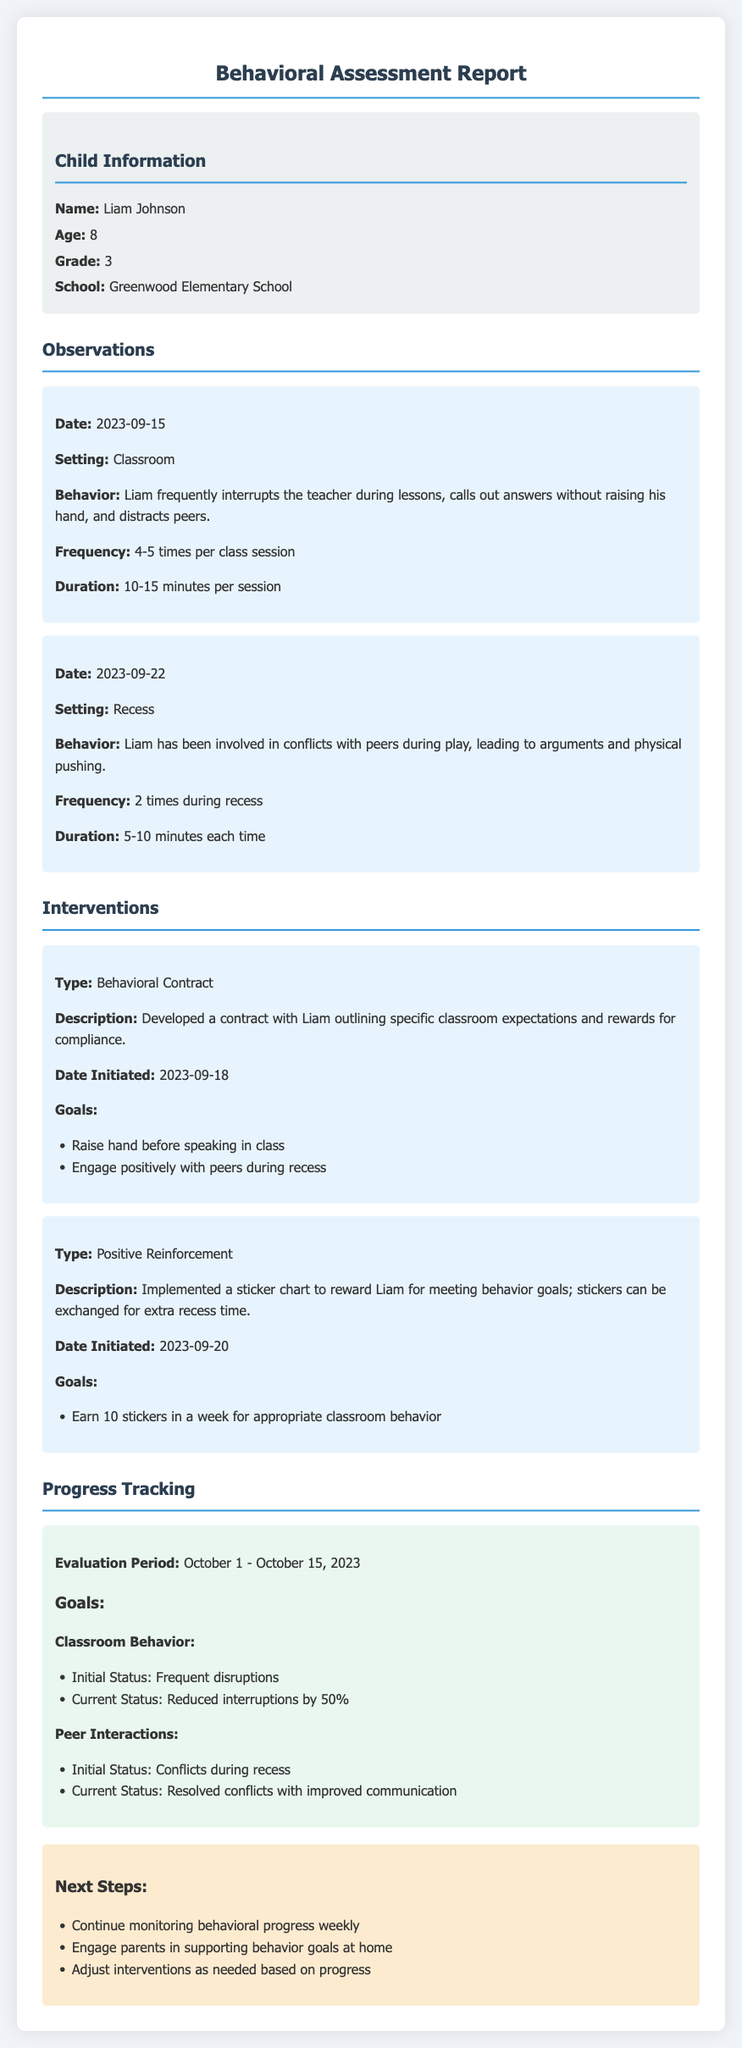What is the child's name? The child's name is stated in the child information section of the document.
Answer: Liam Johnson How old is Liam? The age of Liam is provided in the child information section.
Answer: 8 What type of behavioral intervention involves a sticker chart? This intervention type is mentioned under the interventions section of the document.
Answer: Positive Reinforcement What was Liam's current status for classroom behavior? This status is found in the progress tracking section that evaluates Liam's behavior.
Answer: Reduced interruptions by 50% When was the behavioral contract initiated? The date when the behavioral contract was developed is included in the interventions section.
Answer: 2023-09-18 What were the goals for peer interactions? The goals for peer interactions can be found in the interventions section of the report.
Answer: Engage positively with peers during recess What is the frequency of Liam calling out answers during class? This information is noted in the observations section where Liam's classroom behavior is detailed.
Answer: 4-5 times per class session What is the focus of the next steps for Liam's behavioral goals? The next steps are presented at the end of the document under the Next Steps section.
Answer: Continue monitoring behavioral progress weekly 